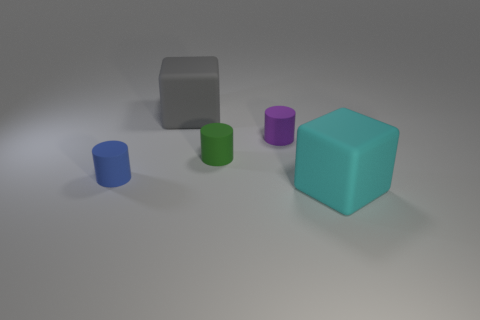Add 1 tiny gray metal things. How many objects exist? 6 Subtract all cylinders. How many objects are left? 2 Add 2 matte blocks. How many matte blocks exist? 4 Subtract 0 green spheres. How many objects are left? 5 Subtract all small blue shiny cylinders. Subtract all cyan matte blocks. How many objects are left? 4 Add 3 small green matte cylinders. How many small green matte cylinders are left? 4 